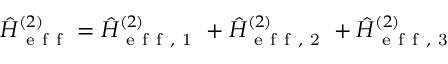<formula> <loc_0><loc_0><loc_500><loc_500>\hat { H } _ { e f f } ^ { ( 2 ) } = \hat { H } _ { e f f , 1 } ^ { ( 2 ) } + \hat { H } _ { e f f , 2 } ^ { ( 2 ) } + \hat { H } _ { e f f , 3 } ^ { ( 2 ) }</formula> 